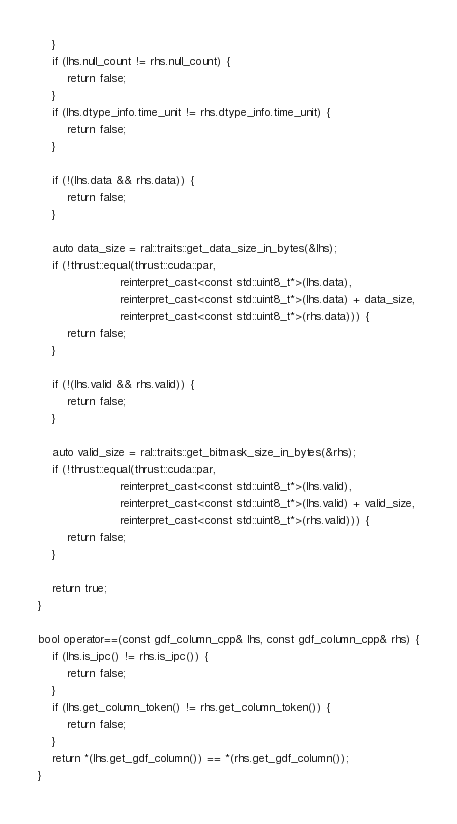Convert code to text. <code><loc_0><loc_0><loc_500><loc_500><_Cuda_>    }
    if (lhs.null_count != rhs.null_count) {
        return false;
    }
    if (lhs.dtype_info.time_unit != rhs.dtype_info.time_unit) {
        return false;
    }

    if (!(lhs.data && rhs.data)) {
        return false;
    }

    auto data_size = ral::traits::get_data_size_in_bytes(&lhs);
    if (!thrust::equal(thrust::cuda::par,
                       reinterpret_cast<const std::uint8_t*>(lhs.data),
                       reinterpret_cast<const std::uint8_t*>(lhs.data) + data_size,
                       reinterpret_cast<const std::uint8_t*>(rhs.data))) {
        return false;
    }

    if (!(lhs.valid && rhs.valid)) {
        return false;
    }

    auto valid_size = ral::traits::get_bitmask_size_in_bytes(&rhs);
    if (!thrust::equal(thrust::cuda::par,
                       reinterpret_cast<const std::uint8_t*>(lhs.valid),
                       reinterpret_cast<const std::uint8_t*>(lhs.valid) + valid_size,
                       reinterpret_cast<const std::uint8_t*>(rhs.valid))) {
        return false;
    }

    return true;
}

bool operator==(const gdf_column_cpp& lhs, const gdf_column_cpp& rhs) {
    if (lhs.is_ipc() != rhs.is_ipc()) {
        return false;
    }
    if (lhs.get_column_token() != rhs.get_column_token()) {
        return false;
    }
    return *(lhs.get_gdf_column()) == *(rhs.get_gdf_column());
}
</code> 